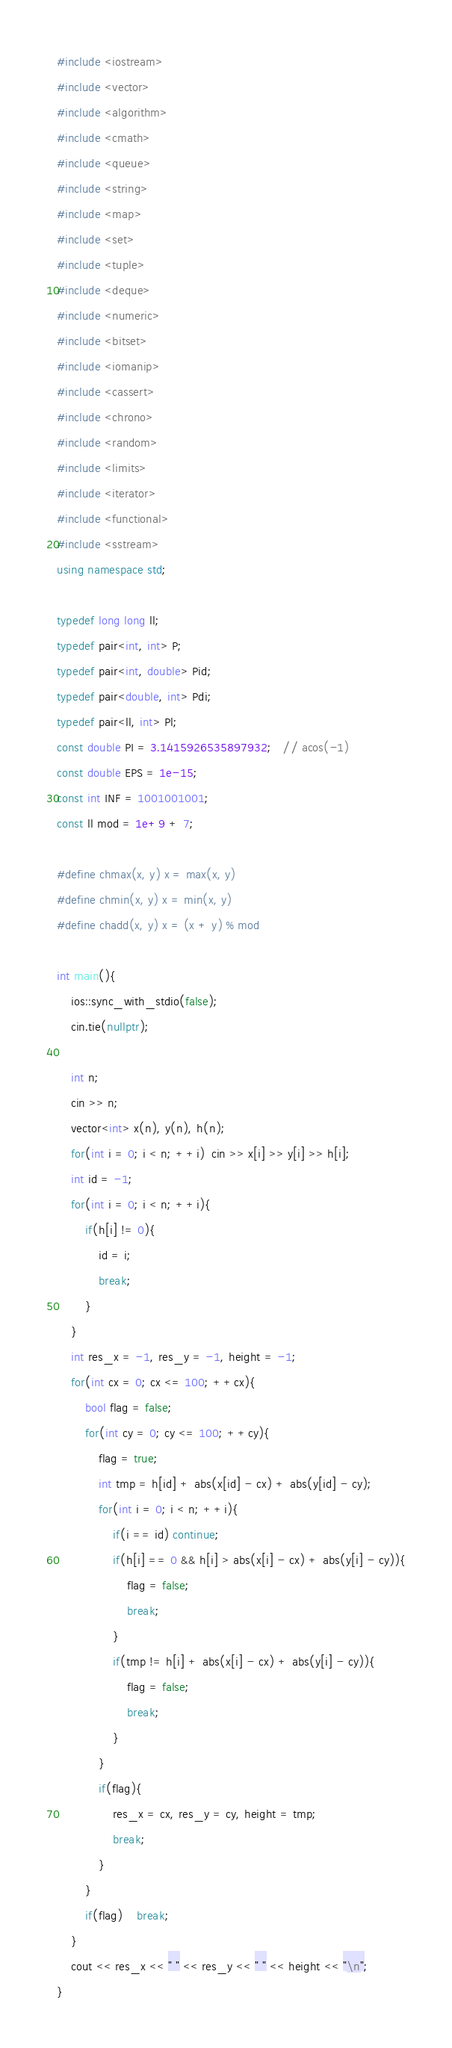Convert code to text. <code><loc_0><loc_0><loc_500><loc_500><_C++_>#include <iostream>
#include <vector>
#include <algorithm>
#include <cmath>
#include <queue>
#include <string>
#include <map>
#include <set>
#include <tuple>
#include <deque>
#include <numeric>
#include <bitset>
#include <iomanip>
#include <cassert>
#include <chrono>
#include <random>
#include <limits>
#include <iterator>
#include <functional>
#include <sstream>
using namespace std;

typedef long long ll;
typedef pair<int, int> P;
typedef pair<int, double> Pid;
typedef pair<double, int> Pdi;
typedef pair<ll, int> Pl;
const double PI = 3.1415926535897932;   // acos(-1)
const double EPS = 1e-15;
const int INF = 1001001001;
const ll mod = 1e+9 + 7;

#define chmax(x, y) x = max(x, y)
#define chmin(x, y) x = min(x, y)
#define chadd(x, y) x = (x + y) % mod

int main(){
    ios::sync_with_stdio(false);
    cin.tie(nullptr);

    int n;
    cin >> n;
    vector<int> x(n), y(n), h(n);
    for(int i = 0; i < n; ++i)  cin >> x[i] >> y[i] >> h[i];
    int id = -1;
    for(int i = 0; i < n; ++i){
        if(h[i] != 0){
            id = i;
            break;
        }
    }
    int res_x = -1, res_y = -1, height = -1;
    for(int cx = 0; cx <= 100; ++cx){
        bool flag = false;
        for(int cy = 0; cy <= 100; ++cy){
            flag = true;
            int tmp = h[id] + abs(x[id] - cx) + abs(y[id] - cy);
            for(int i = 0; i < n; ++i){
                if(i == id) continue;
                if(h[i] == 0 && h[i] > abs(x[i] - cx) + abs(y[i] - cy)){
                    flag = false;
                    break;
                }
                if(tmp != h[i] + abs(x[i] - cx) + abs(y[i] - cy)){
                    flag = false;
                    break;
                }
            }
            if(flag){
                res_x = cx, res_y = cy, height = tmp;
                break;
            }
        }
        if(flag)    break;
    }
    cout << res_x << " " << res_y << " " << height << "\n";
}</code> 